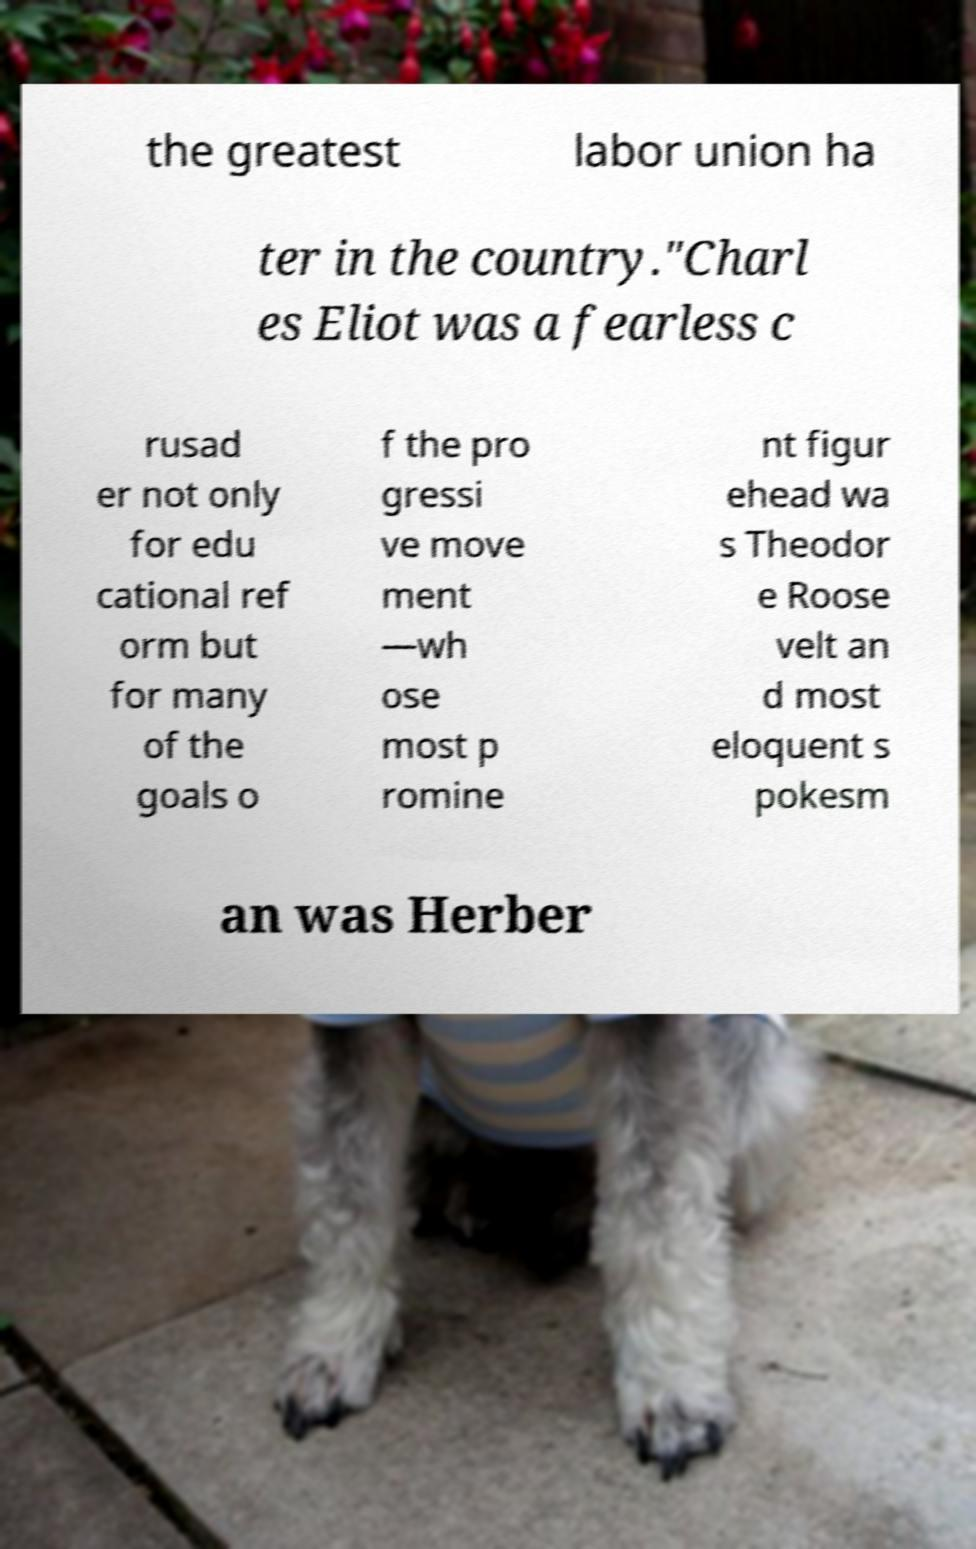Please identify and transcribe the text found in this image. the greatest labor union ha ter in the country."Charl es Eliot was a fearless c rusad er not only for edu cational ref orm but for many of the goals o f the pro gressi ve move ment —wh ose most p romine nt figur ehead wa s Theodor e Roose velt an d most eloquent s pokesm an was Herber 